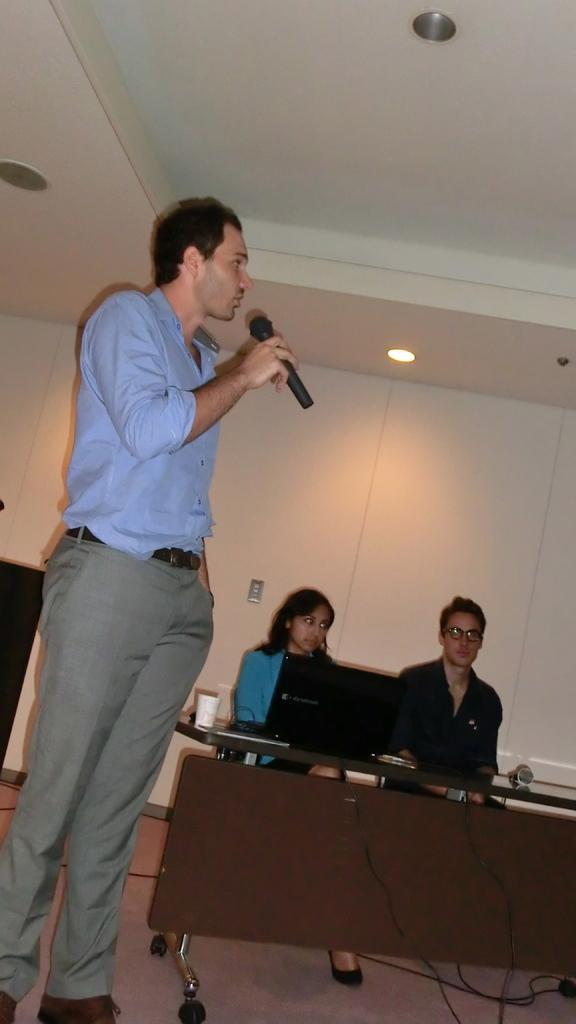In one or two sentences, can you explain what this image depicts? Here on the left side we can see a person standing and speaking something in the microphone present in his hand and beside him we can see a couple of persons sitting on a chair with table in front of them having laptops on it and cups present and at the top we can see lights present 